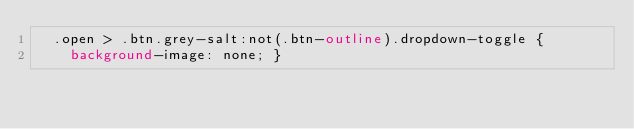<code> <loc_0><loc_0><loc_500><loc_500><_CSS_>  .open > .btn.grey-salt:not(.btn-outline).dropdown-toggle {
    background-image: none; }</code> 